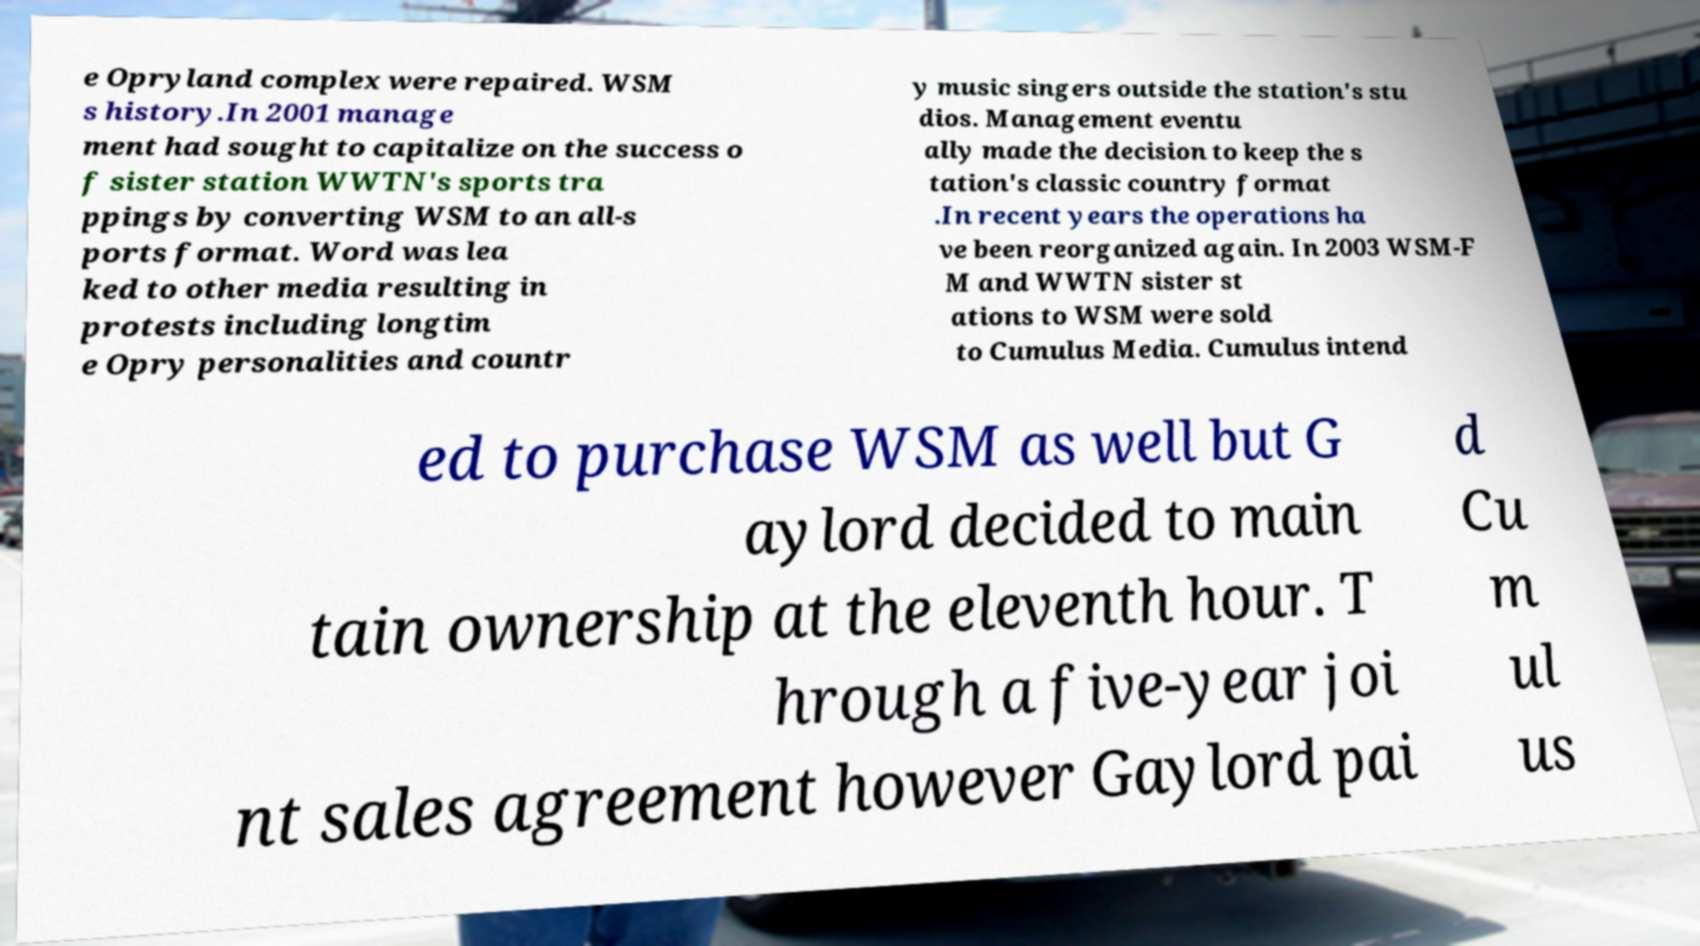Can you accurately transcribe the text from the provided image for me? e Opryland complex were repaired. WSM s history.In 2001 manage ment had sought to capitalize on the success o f sister station WWTN's sports tra ppings by converting WSM to an all-s ports format. Word was lea ked to other media resulting in protests including longtim e Opry personalities and countr y music singers outside the station's stu dios. Management eventu ally made the decision to keep the s tation's classic country format .In recent years the operations ha ve been reorganized again. In 2003 WSM-F M and WWTN sister st ations to WSM were sold to Cumulus Media. Cumulus intend ed to purchase WSM as well but G aylord decided to main tain ownership at the eleventh hour. T hrough a five-year joi nt sales agreement however Gaylord pai d Cu m ul us 